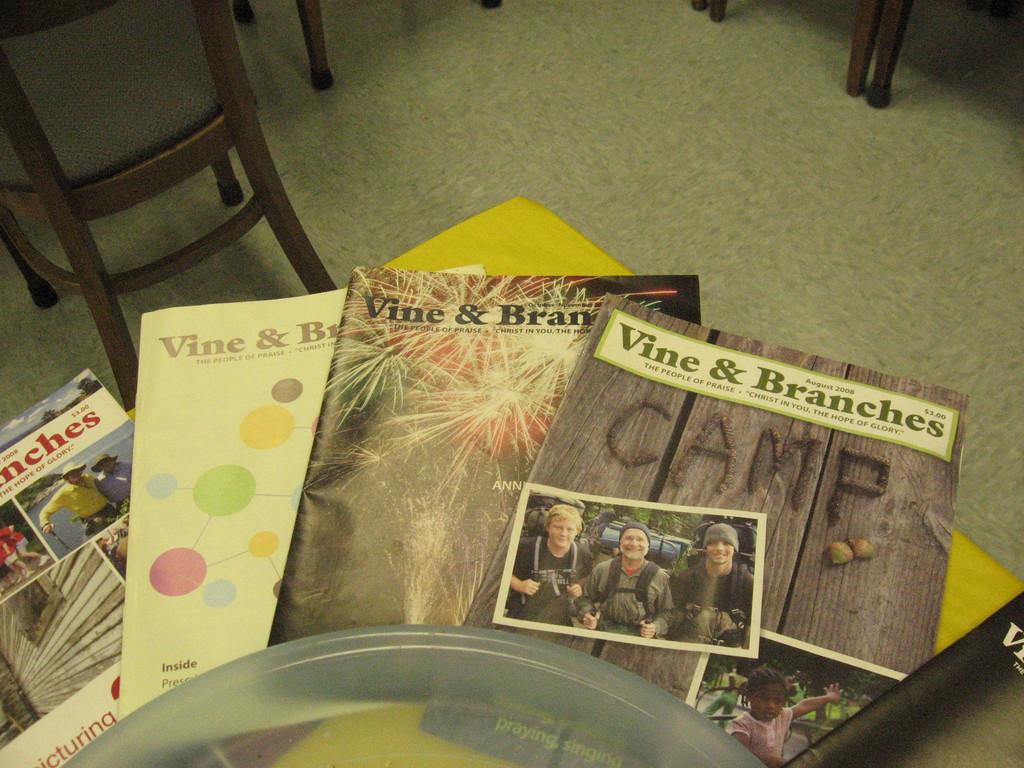<image>
Describe the image concisely. A group of magazines from Vine & branches 